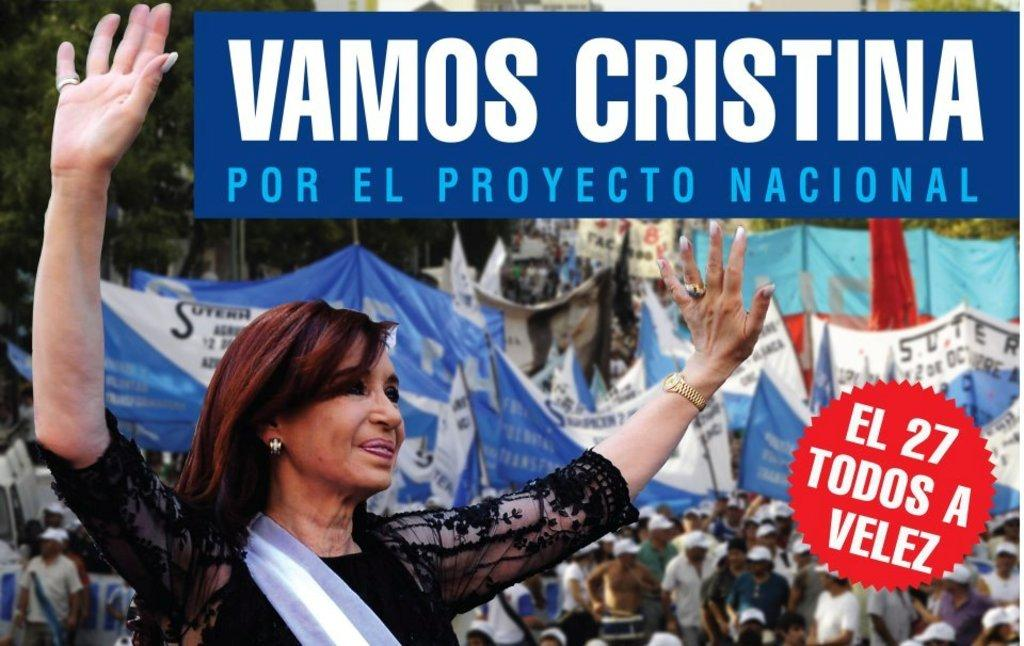What can be seen in the image? There are people in the image. Are there any specific objects or features in the image? Yes, there are banners in the image. Can you describe the woman in the image? There is a woman in the front of the image, and she is smiling. What type of natural environment is visible in the image? There are trees visible in the image. Is there any text or writing present in the image? Yes, there is text or writing present in the image. How many wings can be seen on the woman in the image? There are no wings visible on the woman in the image. What type of protest is being held in the image? There is no protest present in the image; it features people and banners, but no indication of a protest. 